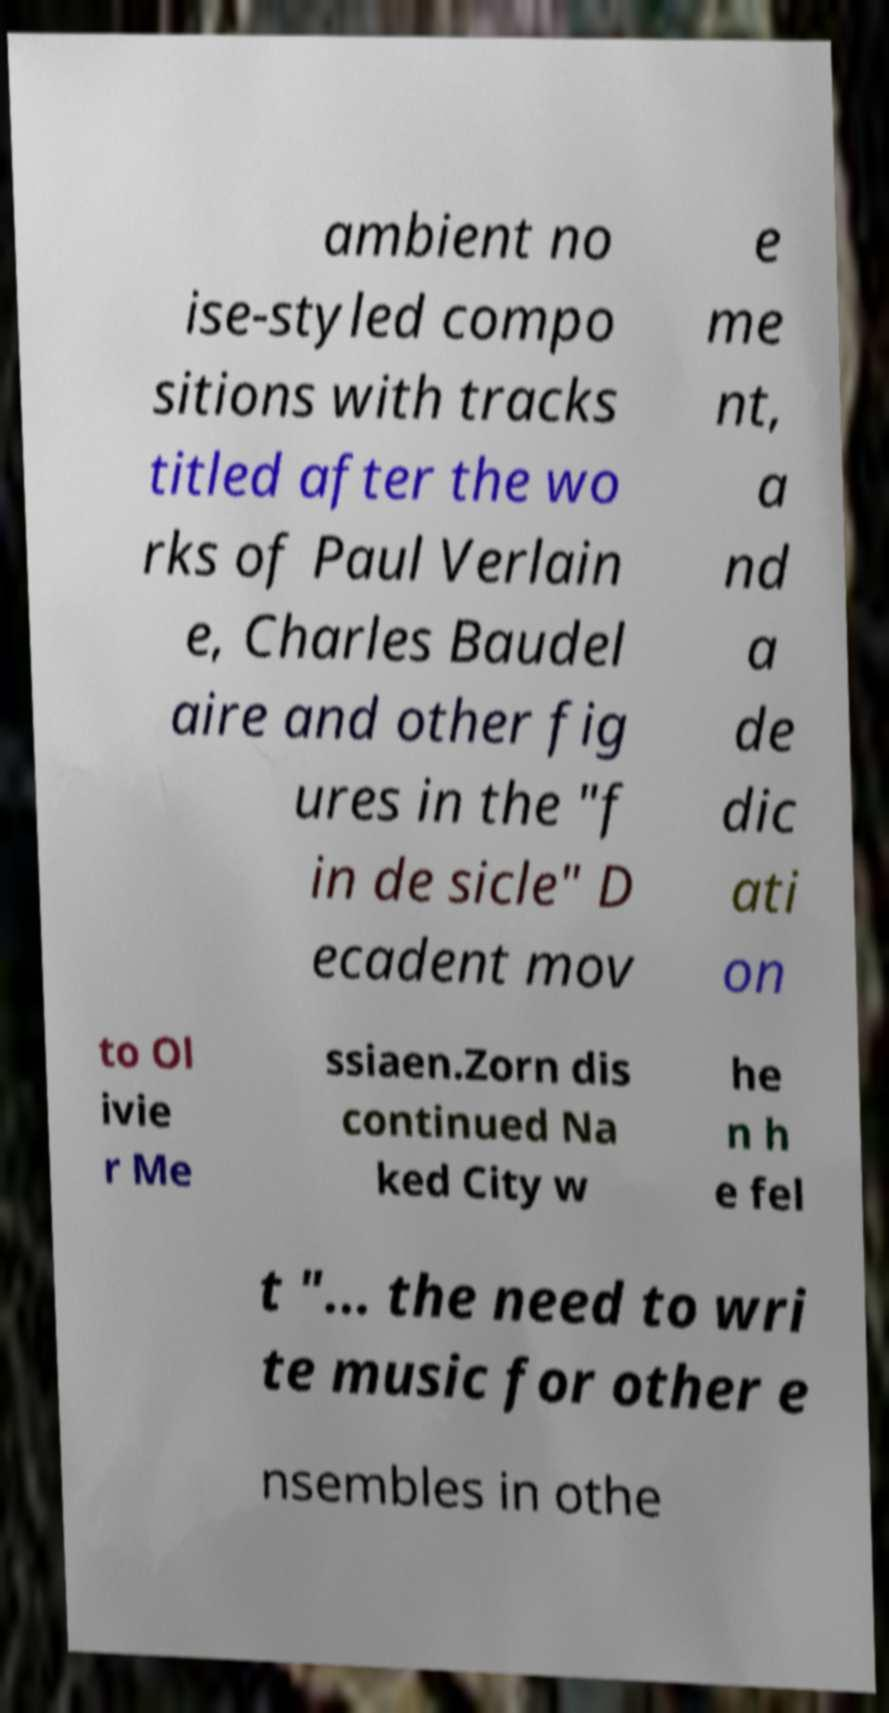Can you read and provide the text displayed in the image?This photo seems to have some interesting text. Can you extract and type it out for me? ambient no ise-styled compo sitions with tracks titled after the wo rks of Paul Verlain e, Charles Baudel aire and other fig ures in the "f in de sicle" D ecadent mov e me nt, a nd a de dic ati on to Ol ivie r Me ssiaen.Zorn dis continued Na ked City w he n h e fel t "... the need to wri te music for other e nsembles in othe 